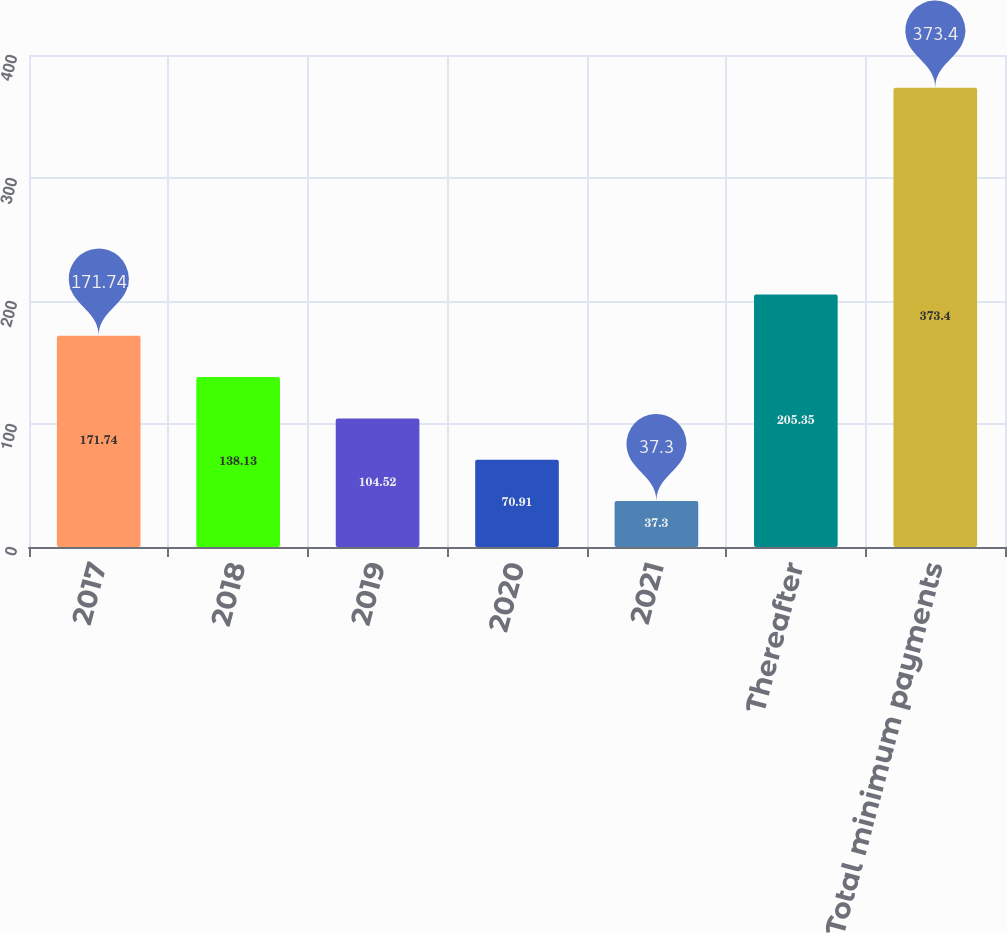Convert chart. <chart><loc_0><loc_0><loc_500><loc_500><bar_chart><fcel>2017<fcel>2018<fcel>2019<fcel>2020<fcel>2021<fcel>Thereafter<fcel>Total minimum payments<nl><fcel>171.74<fcel>138.13<fcel>104.52<fcel>70.91<fcel>37.3<fcel>205.35<fcel>373.4<nl></chart> 